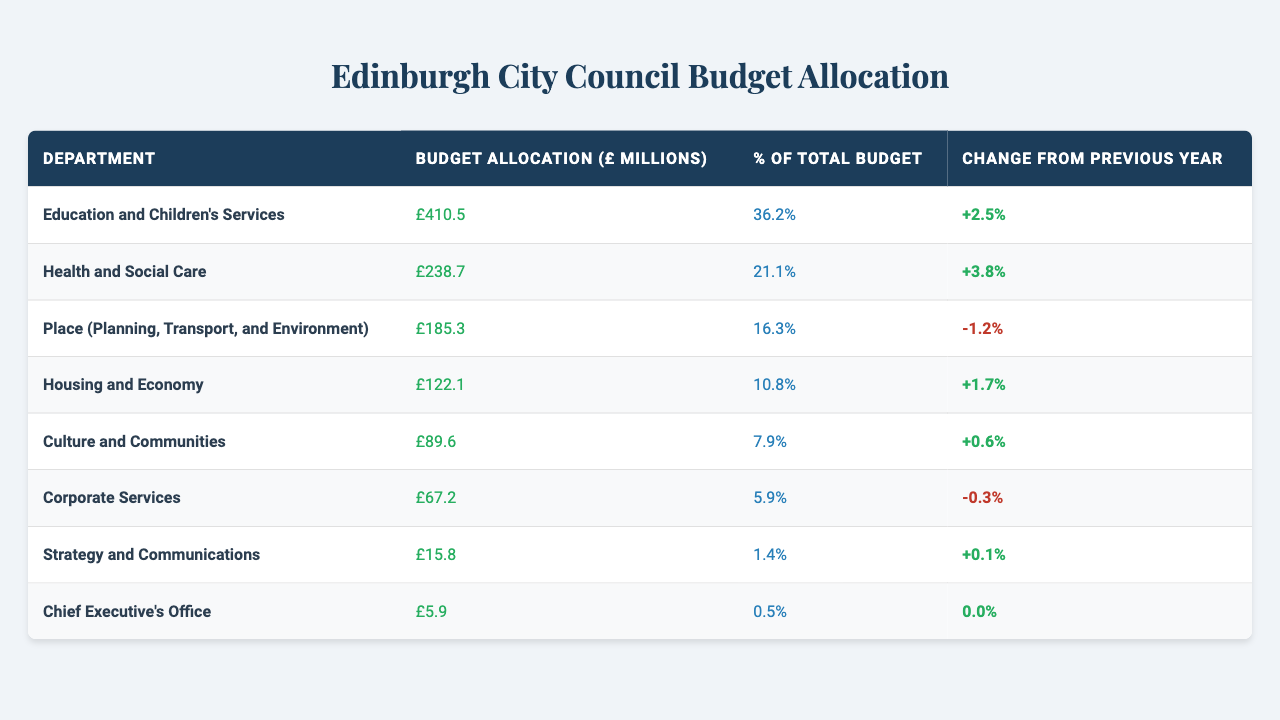What is the budget allocation for the Education and Children's Services department? The table lists the budget allocation for each department, and for Education and Children's Services, it is specified as £410.5 million.
Answer: £410.5 million Which department has the largest budget allocation? By reviewing the budget allocations in the table, Education and Children's Services has the highest allocation at £410.5 million.
Answer: Education and Children's Services What percentage of the total budget is allocated to Culture and Communities? The table shows that Culture and Communities is allocated 7.9% of the total budget.
Answer: 7.9% Did any department experience a decrease in budget allocation compared to the previous year? A negative change from the previous year indicates a decrease. The Place department shows a decrease of -1.2%.
Answer: Yes What is the total budget allocation across all departments? To find the total budget allocation, sum up each department's allocation: 410.5 + 238.7 + 185.3 + 122.1 + 89.6 + 67.2 + 15.8 + 5.9 = 1,130.1 million.
Answer: £1,130.1 million Which department had the smallest budget allocation? The smallest budget allocation in the table is for the Chief Executive's Office, which is £5.9 million.
Answer: Chief Executive's Office How much has the budget for Health and Social Care changed from the previous year? The table indicates a change of +3.8% for Health and Social Care, meaning its budget increased this year.
Answer: +3.8% What is the difference in budget allocation between the Housing and Economy department and the Education and Children's Services department? The difference can be calculated by subtracting the allocation of Housing and Economy (£122.1 million) from Education and Children's Services (£410.5 million), which is 410.5 - 122.1 = 288.4 million.
Answer: £288.4 million If we combine the budgets of Corporate Services and Strategy and Communications, what is the total? Adding the allocations for Corporate Services (£67.2 million) and Strategy and Communications (£15.8 million) yields a total of 67.2 + 15.8 = 83 million.
Answer: £83 million Which department has seen a budget increase, and by how much? Health and Social Care has seen an increase of 3.8%, while the Education and Children's Services has also increased by 2.5%, meaning both are experiencing a budget increase.
Answer: Health and Social Care (+3.8%) and Education and Children's Services (+2.5%) 